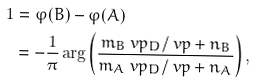Convert formula to latex. <formula><loc_0><loc_0><loc_500><loc_500>1 & = \varphi ( B ) - \varphi ( A ) \\ & = - \frac { 1 } { \pi } \arg \left ( \frac { m _ { B } \ v p _ { D } / \ v p + n _ { B } } { m _ { A } \ v p _ { D } / \ v p + n _ { A } } \right ) ,</formula> 